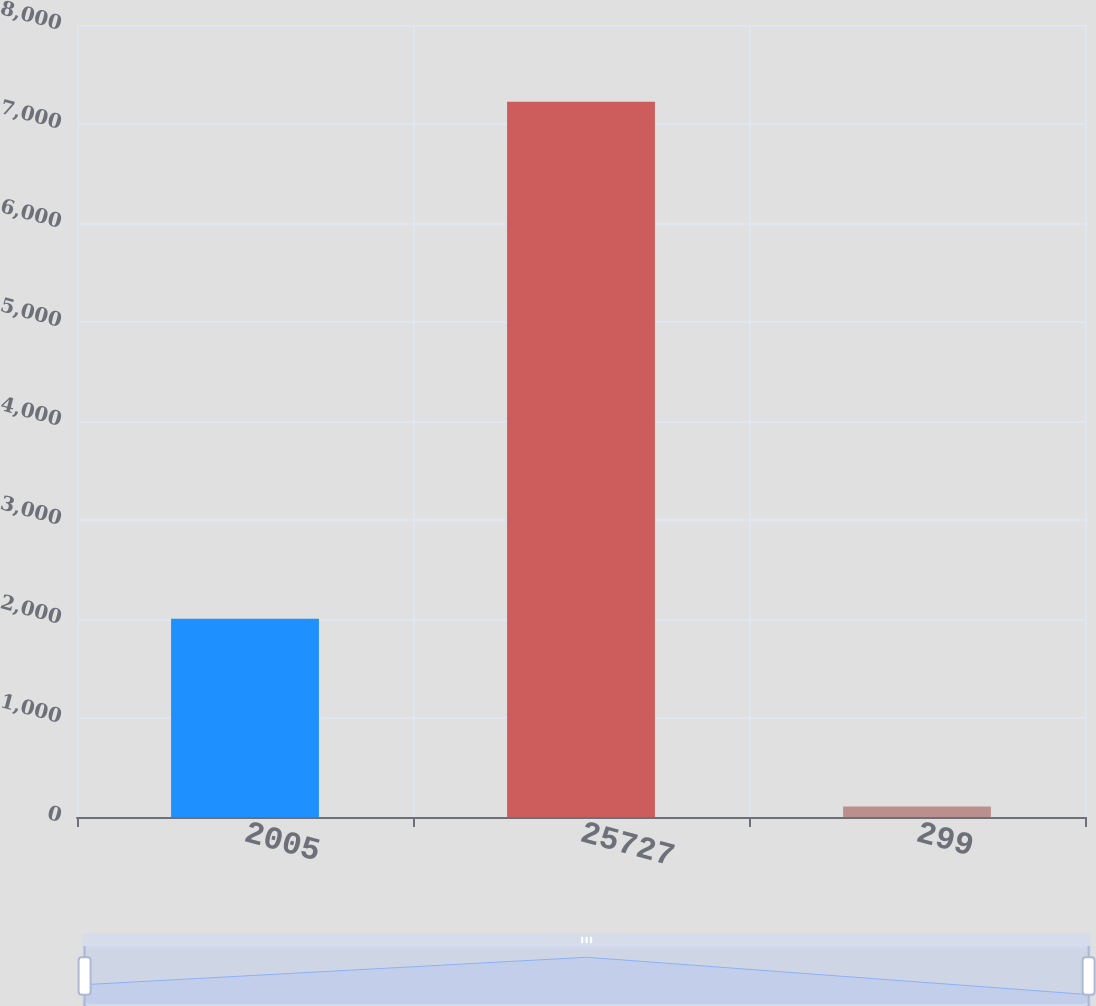Convert chart. <chart><loc_0><loc_0><loc_500><loc_500><bar_chart><fcel>2005<fcel>25727<fcel>299<nl><fcel>2003<fcel>7225<fcel>107<nl></chart> 